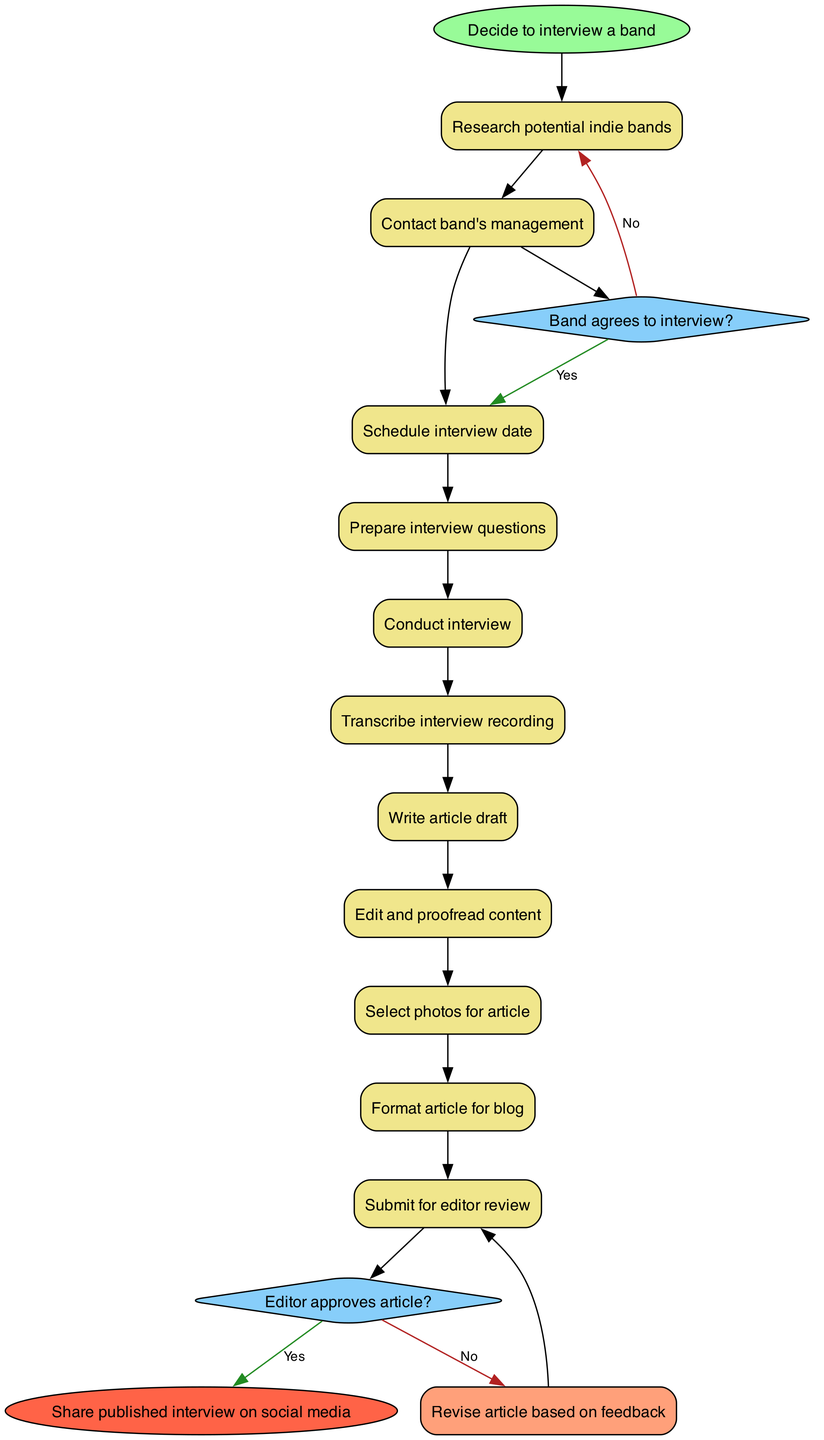What is the first activity in the diagram? The first activity is represented directly after the start node, which is "Research potential indie bands."
Answer: Research potential indie bands How many activities are there in total? By counting the activities listed, there are 11 activities in the diagram including the start and end nodes.
Answer: 11 What happens if the band does not agree to the interview? If the band does not agree, the process leads back to "Research potential indie bands," indicating that research will need to be conducted again.
Answer: Research potential indie bands What is the final step of the process? The final step is indicated by the end node, which states "Share published interview on social media."
Answer: Share published interview on social media What question is posed after conducting the interview? After conducting the interview, the question posed is "Editor approves article?" which determines the next steps in the publishing process.
Answer: Editor approves article? What is the outcome if the editor does not approve the article? If the editor does not approve the article, it indicates a need to "Revise article based on feedback," which the diagram specifies as the next step.
Answer: Revise article based on feedback How many edges connect the activities? By tracking the flow of the diagram, there are 10 edges connecting the activities between the start and the end nodes.
Answer: 10 Which activity immediately follows the transcribing of the interview? Immediately following the transcribing of the interview is the activity "Write article draft," as shown by the direct edge leading from one to the other.
Answer: Write article draft What color is used for decision nodes in the diagram? The decision nodes are represented in a diamond shape and are filled with the color #87CEFA, which is a light blue.
Answer: Light blue 